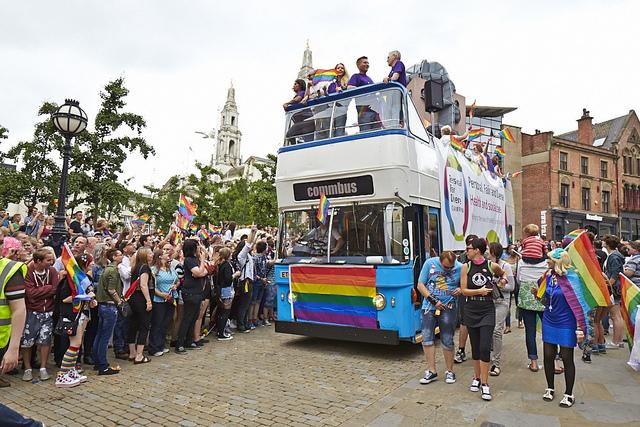How many street lamps are in this scene?
Answer briefly. 1. Is this a parade?
Short answer required. Yes. What kind of banners and flags are being held up?
Answer briefly. Rainbow. 